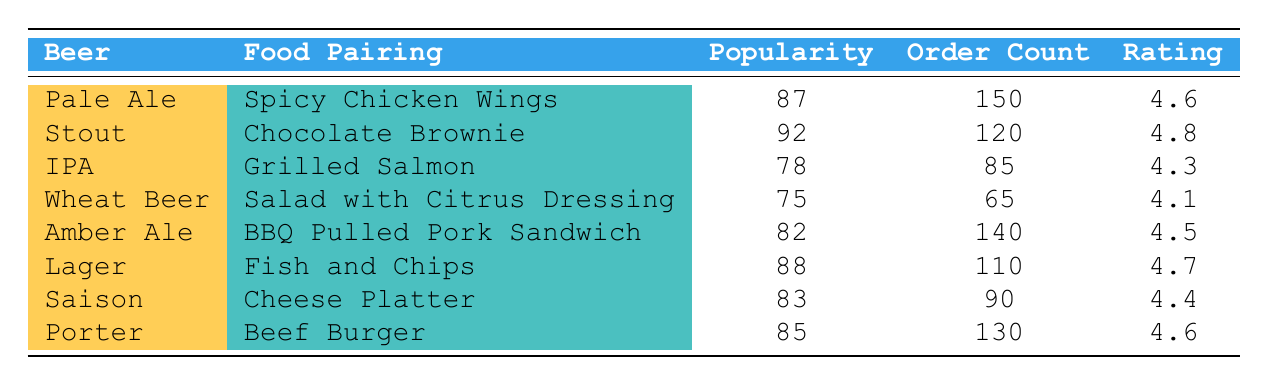What is the most popular beer and food pairing based on the popularity score? The table shows the popularity scores for each beer-food pairing. The highest score is 92, which corresponds to the "Stout" and "Chocolate Brownie" pairing.
Answer: Stout and Chocolate Brownie How many orders were made for Pale Ale paired with Spicy Chicken Wings? The order count for the pairing of Pale Ale with Spicy Chicken Wings is directly listed in the table as 150.
Answer: 150 Which beer has the lowest customer rating? The customer ratings for each pairing are listed, and Wheat Beer with Salad has the lowest rating of 4.1.
Answer: Wheat Beer What is the average popularity score of all the beer-food pairings? To find the average, sum all the popularity scores (87 + 92 + 78 + 75 + 82 + 88 + 83 + 85) = 690. There are 8 pairings, so the average is 690 / 8 = 86.25.
Answer: 86.25 Is Lager paired with Fish and Chips more popular than Amber Ale with BBQ Pulled Pork Sandwich? Comparing the popularity scores, Lager with Fish and Chips has a score of 88, while Amber Ale with BBQ Pulled Pork Sandwich has a score of 82. Since 88 > 82, the statement is true.
Answer: Yes What are the top two food pairings based on order count? The order counts are compared, with Spicy Chicken Wings at 150 orders and BBQ Pulled Pork Sandwich at 140 orders. These are the top two pairings.
Answer: Spicy Chicken Wings, BBQ Pulled Pork Sandwich Which beer has a higher customer rating: Porter or IPA? The customer ratings for Porter is 4.6 and for IPA is 4.3. Since 4.6 > 4.3, Porter has a higher rating than IPA.
Answer: Porter What is the difference in order count between the most and least popular beer-food pairings? The most popular pairing is Pale Ale with Spicy Chicken Wings (150 orders) and the least is Wheat Beer with Salad (65 orders). The difference is 150 - 65 = 85.
Answer: 85 How many beers have a customer rating of 4.5 or higher? Looking at the ratings, Stout, Amber Ale, Pale Ale, and Porter all have ratings of 4.5 or more. This gives a total of 4 beers.
Answer: 4 